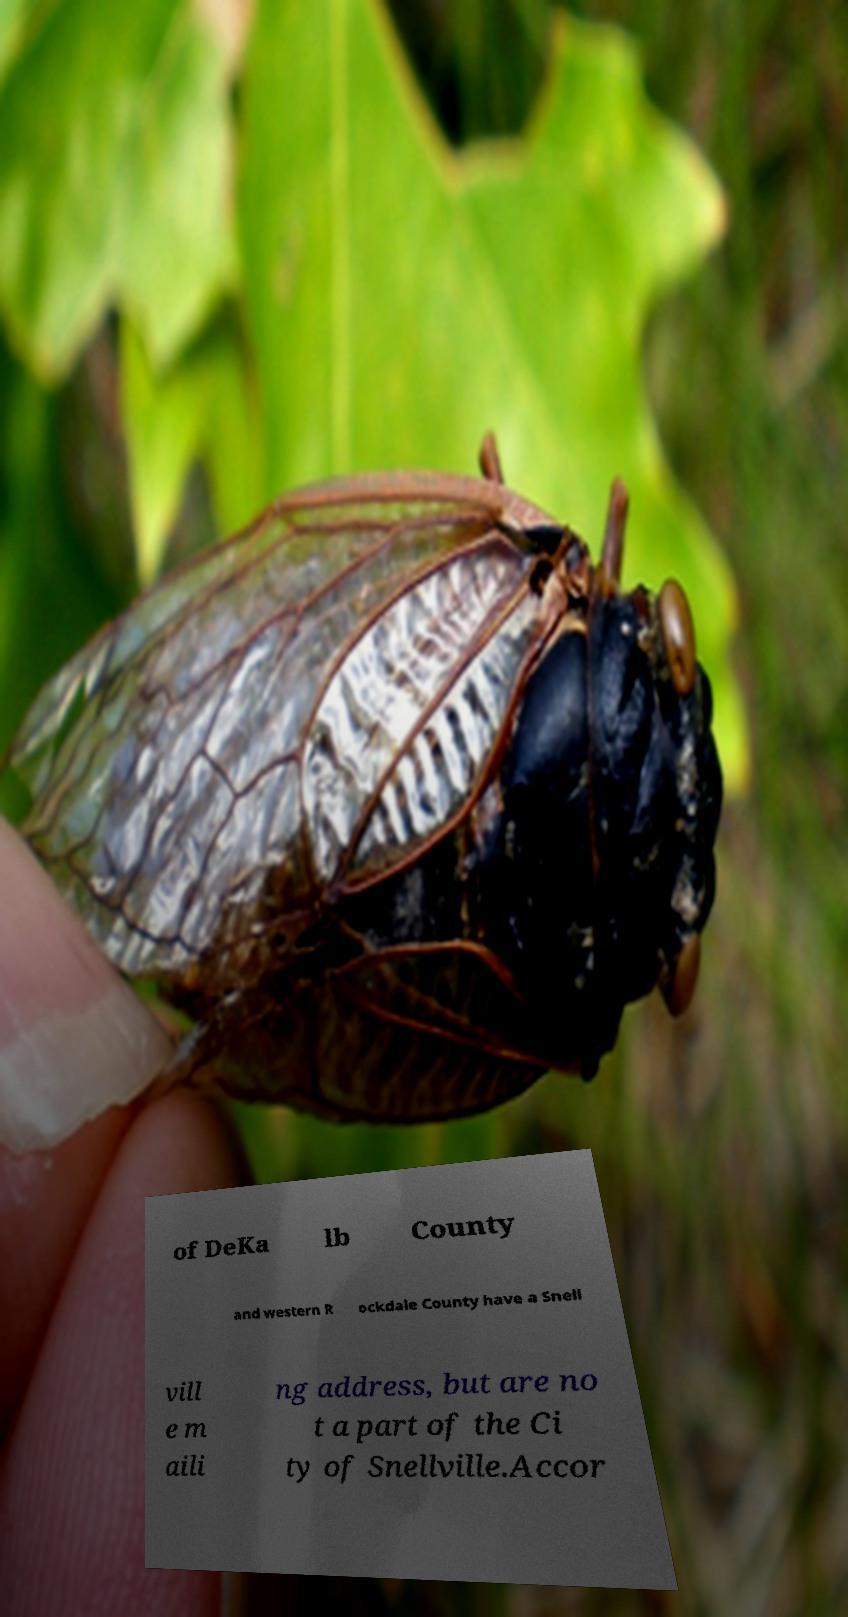Can you read and provide the text displayed in the image?This photo seems to have some interesting text. Can you extract and type it out for me? of DeKa lb County and western R ockdale County have a Snell vill e m aili ng address, but are no t a part of the Ci ty of Snellville.Accor 